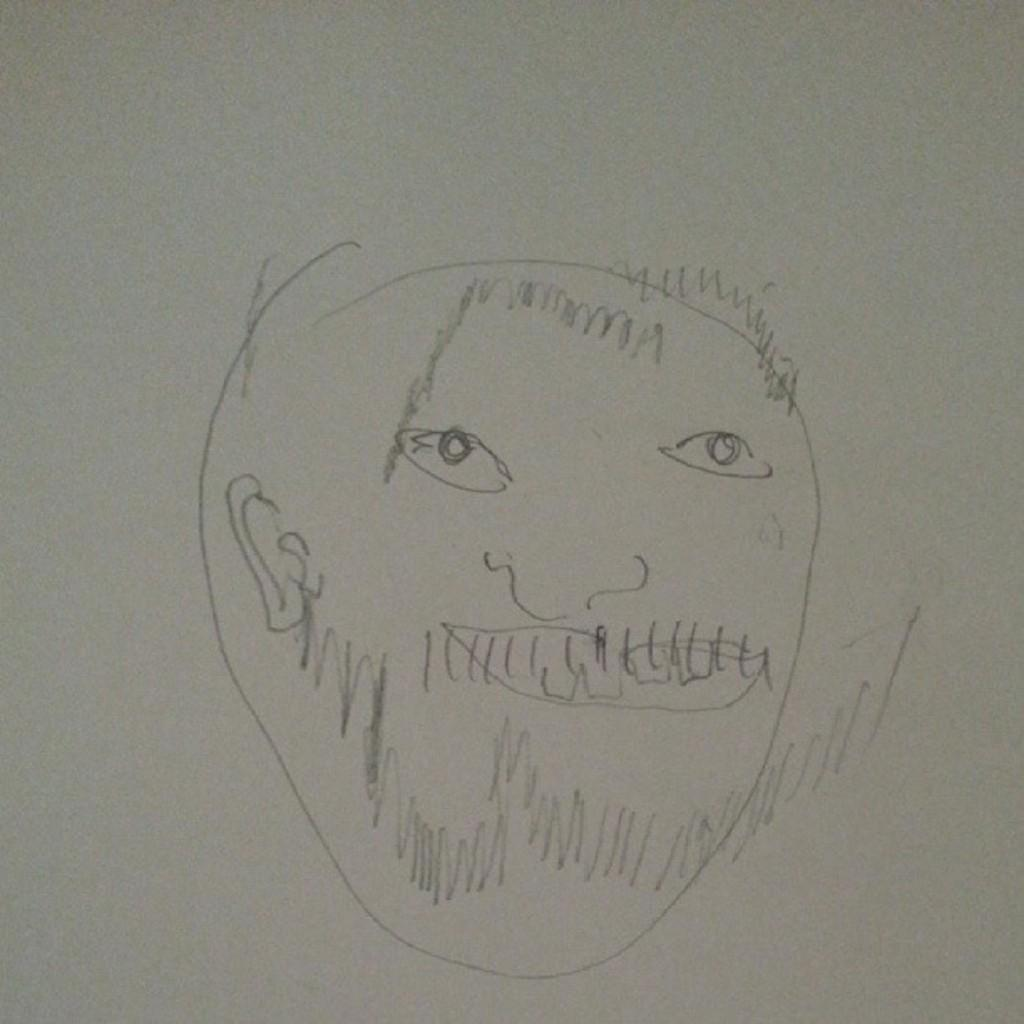What is depicted in the image? There is a drawing in the image. What is the color of the surface on which the drawing is made? The drawing is on a white surface. How many pairs of shoes are visible in the image? There are no shoes present in the image; it features a drawing on a white surface. What type of whip is being used to create the drawing in the image? There is no whip present in the image, and the drawing is likely made with a pen, pencil, or other drawing tool. 